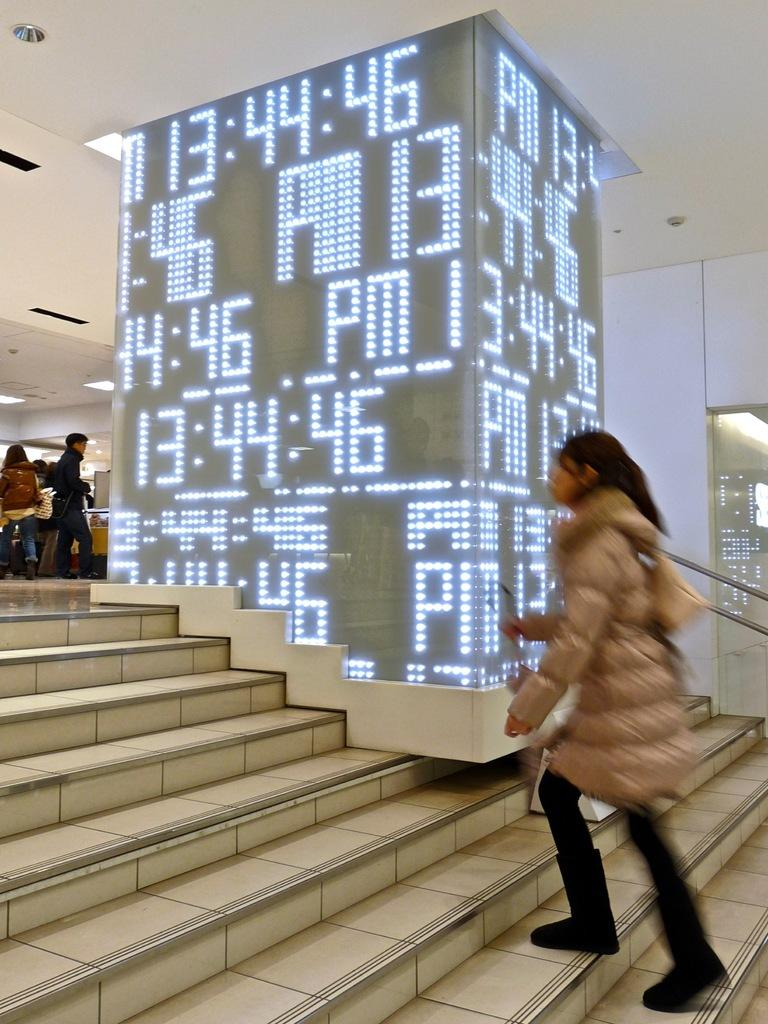How many people are in the image? There are people in the image, but the exact number is not specified. What is the person on the stairs doing? The fact does not specify what the person on the stairs is doing. What architectural feature is present in the image? There are stairs, a railing, a screen, a wall, and a roof in the image. What is on the roof? There are lights and objects attached to the roof in the image. What type of farm animals can be seen grazing in the cemetery in the image? There is no mention of a cemetery or farm animals in the image. The image features people, stairs, a railing, a screen, a wall, a roof, lights, and objects attached to the roof. 